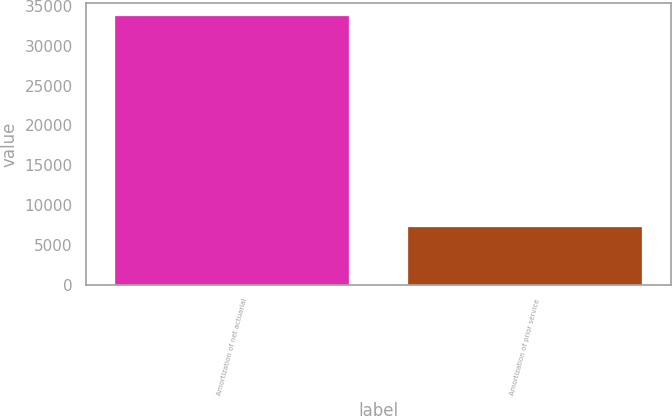Convert chart to OTSL. <chart><loc_0><loc_0><loc_500><loc_500><bar_chart><fcel>Amortization of net actuarial<fcel>Amortization of prior service<nl><fcel>33695<fcel>7235<nl></chart> 